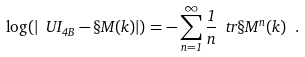<formula> <loc_0><loc_0><loc_500><loc_500>\log ( | \ U I _ { 4 B } - \S M ( k ) | ) = - \sum _ { n = 1 } ^ { \infty } \frac { 1 } { n } \ t r \S M ^ { n } ( k ) \ .</formula> 